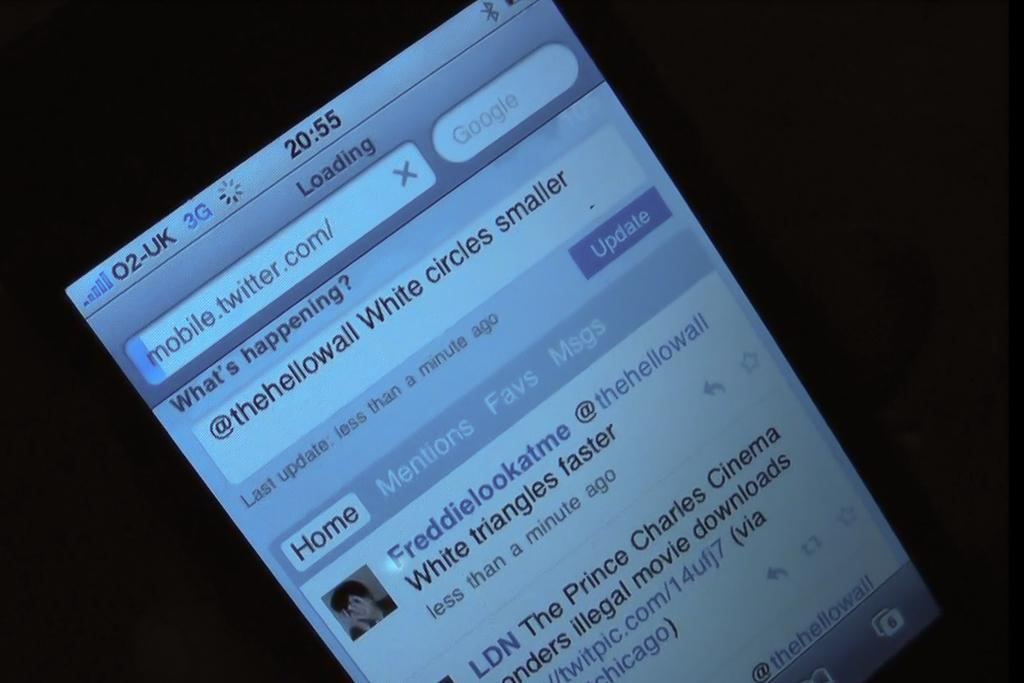<image>
Offer a succinct explanation of the picture presented. The screen of a smart phone with twitter.com pulled up on it. 